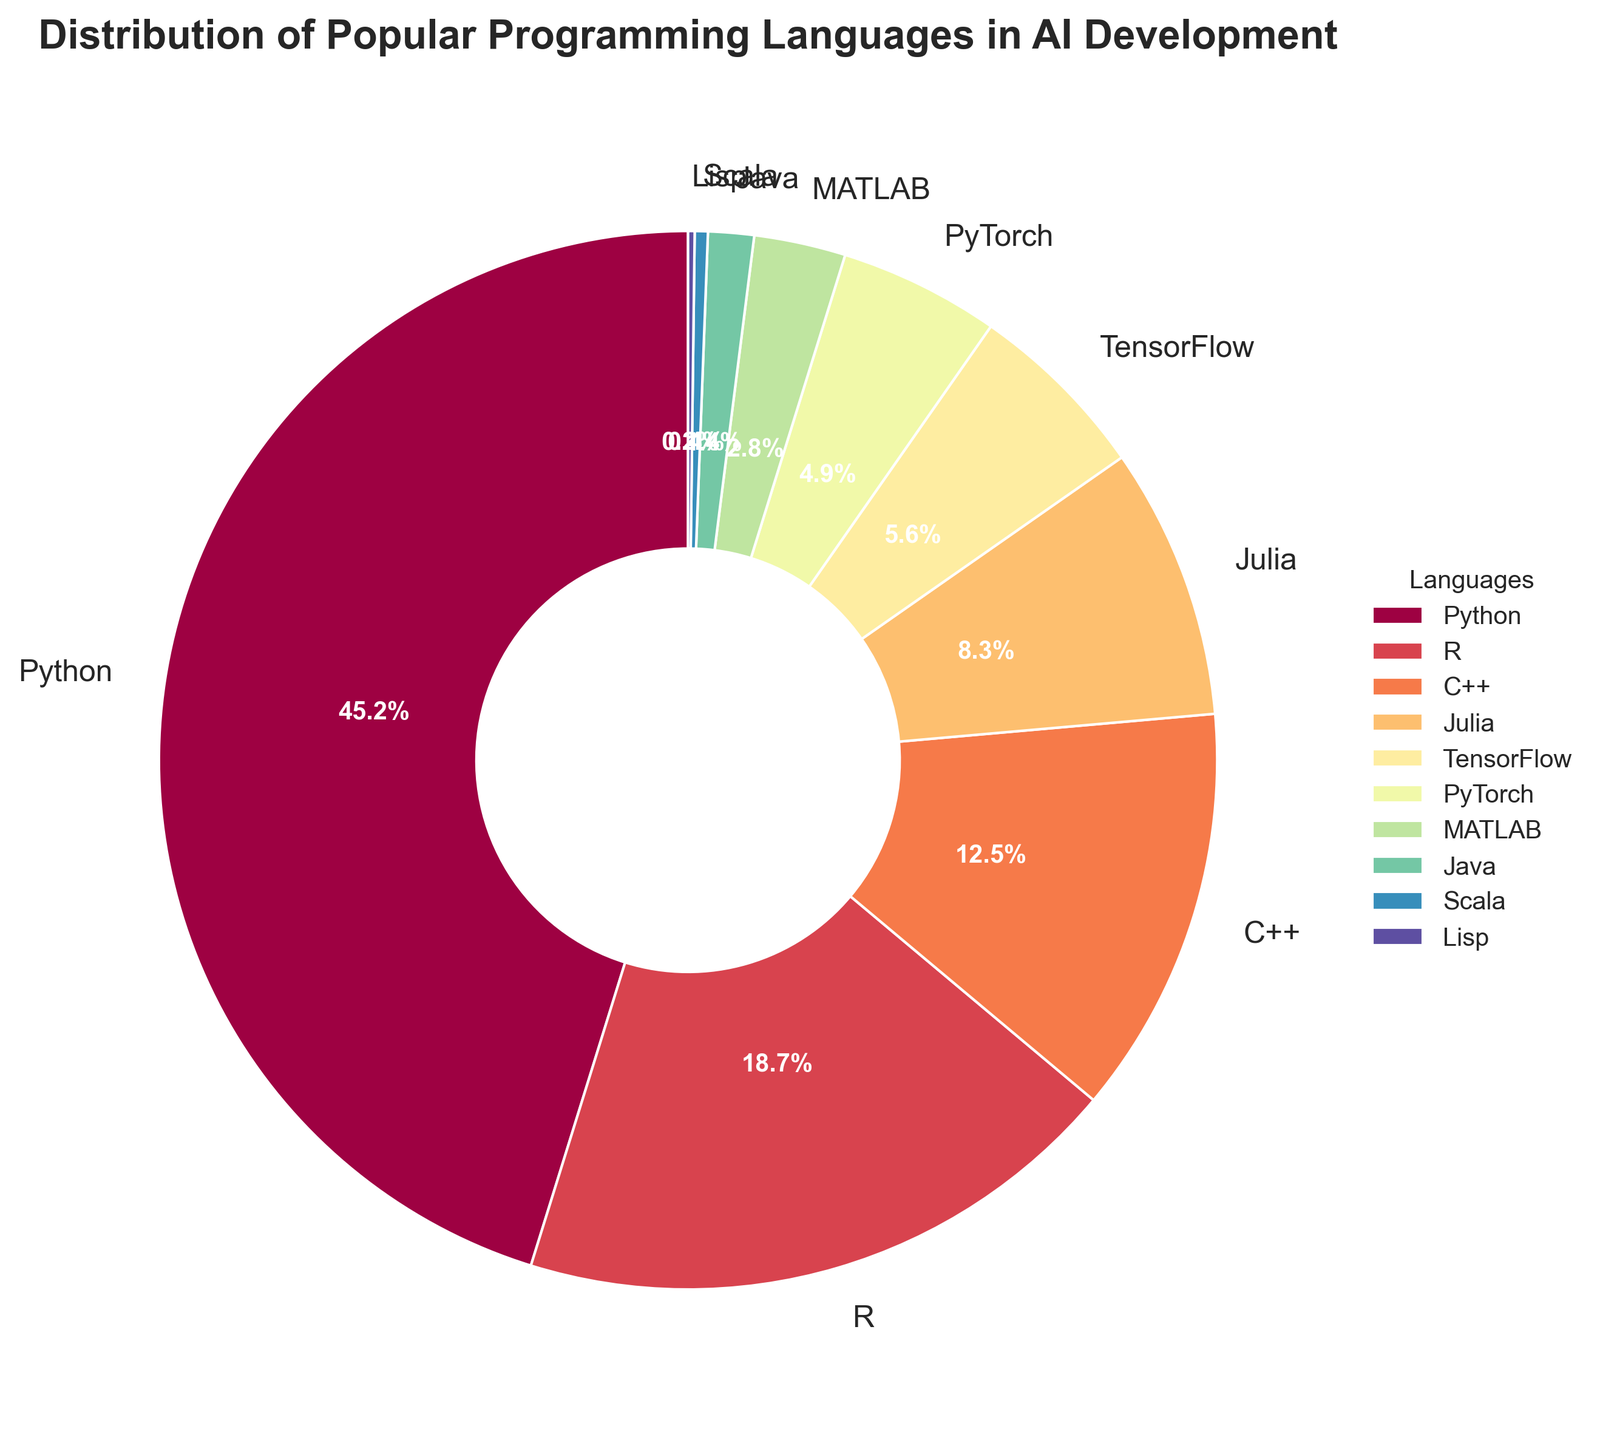Which programming language has the highest percentage usage in AI development? The language with the highest percentage usage is the one with the largest segment in the pie chart. In this case, it's Python.
Answer: Python Which language has the lowest percentage usage in AI development? The language with the smallest segment in the pie chart represents the lowest percentage usage. In this case, it's Lisp.
Answer: Lisp What is the combined percentage of usage for R and Julia? To find the combined percentage, add the percentages for R and Julia. This is 18.7% + 8.3%. Therefore, the combined percentage is 27%.
Answer: 27% Is the usage percentage of TensorFlow greater than that of PyTorch? Compare the sizes of the segments labeled TensorFlow and PyTorch. Here, TensorFlow has 5.6% and PyTorch has 4.9%. Since 5.6% is greater than 4.9%, TensorFlow has a higher percentage than PyTorch.
Answer: Yes Which languages have a usage percentage that is less than 5%? Look for languages in the pie chart that have segments less than 5%. These are PyTorch (4.9%), MATLAB (2.8%), Java (1.4%), Scala (0.4%), and Lisp (0.2%).
Answer: PyTorch, MATLAB, Java, Scala, Lisp How much more is the percentage usage of Python compared to C++? Subtract the percentage of C++ from the percentage of Python. This is 45.2% - 12.5%. The difference is 32.7%.
Answer: 32.7% Which language is shown in the darkest color? The pie chart shows segments in varying colors indicating different languages. The darkest colored segment represents Python.
Answer: Python Are the combined percentages of Java and Scala greater than MATLAB’s percentage? Add the percentages for Java and Scala first, which is 1.4% + 0.4% = 1.8%. Compare this to MATLAB’s percentage, which is 2.8%. Since 1.8% is not greater than 2.8%, the combined percentages of Java and Scala are not greater than MATLAB’s.
Answer: No Which programming languages occupy more than 10% of the total usage? The languages with segments greater than 10% are Python with 45.2%, R with 18.7%, and C++ with 12.5%.
Answer: Python, R, C++ 